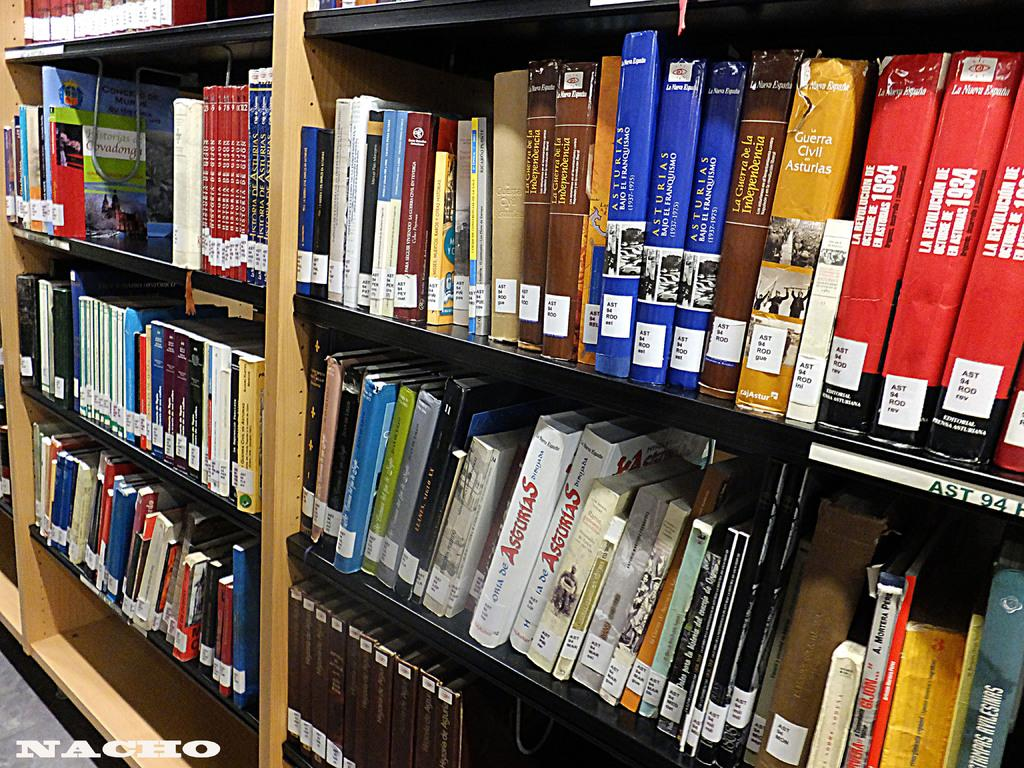<image>
Create a compact narrative representing the image presented. A library bookshelf has many books including Asturias. 